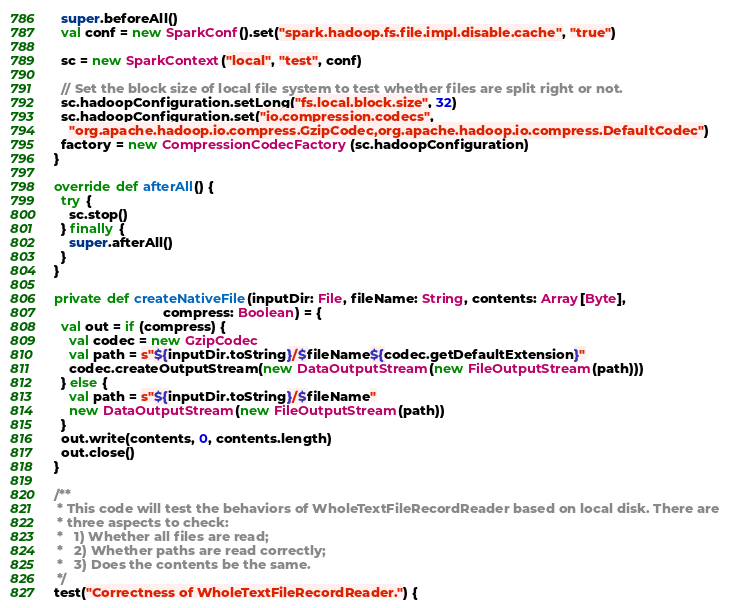<code> <loc_0><loc_0><loc_500><loc_500><_Scala_>    super.beforeAll()
    val conf = new SparkConf().set("spark.hadoop.fs.file.impl.disable.cache", "true")

    sc = new SparkContext("local", "test", conf)

    // Set the block size of local file system to test whether files are split right or not.
    sc.hadoopConfiguration.setLong("fs.local.block.size", 32)
    sc.hadoopConfiguration.set("io.compression.codecs",
      "org.apache.hadoop.io.compress.GzipCodec,org.apache.hadoop.io.compress.DefaultCodec")
    factory = new CompressionCodecFactory(sc.hadoopConfiguration)
  }

  override def afterAll() {
    try {
      sc.stop()
    } finally {
      super.afterAll()
    }
  }

  private def createNativeFile(inputDir: File, fileName: String, contents: Array[Byte],
                               compress: Boolean) = {
    val out = if (compress) {
      val codec = new GzipCodec
      val path = s"${inputDir.toString}/$fileName${codec.getDefaultExtension}"
      codec.createOutputStream(new DataOutputStream(new FileOutputStream(path)))
    } else {
      val path = s"${inputDir.toString}/$fileName"
      new DataOutputStream(new FileOutputStream(path))
    }
    out.write(contents, 0, contents.length)
    out.close()
  }

  /**
   * This code will test the behaviors of WholeTextFileRecordReader based on local disk. There are
   * three aspects to check:
   *   1) Whether all files are read;
   *   2) Whether paths are read correctly;
   *   3) Does the contents be the same.
   */
  test("Correctness of WholeTextFileRecordReader.") {</code> 